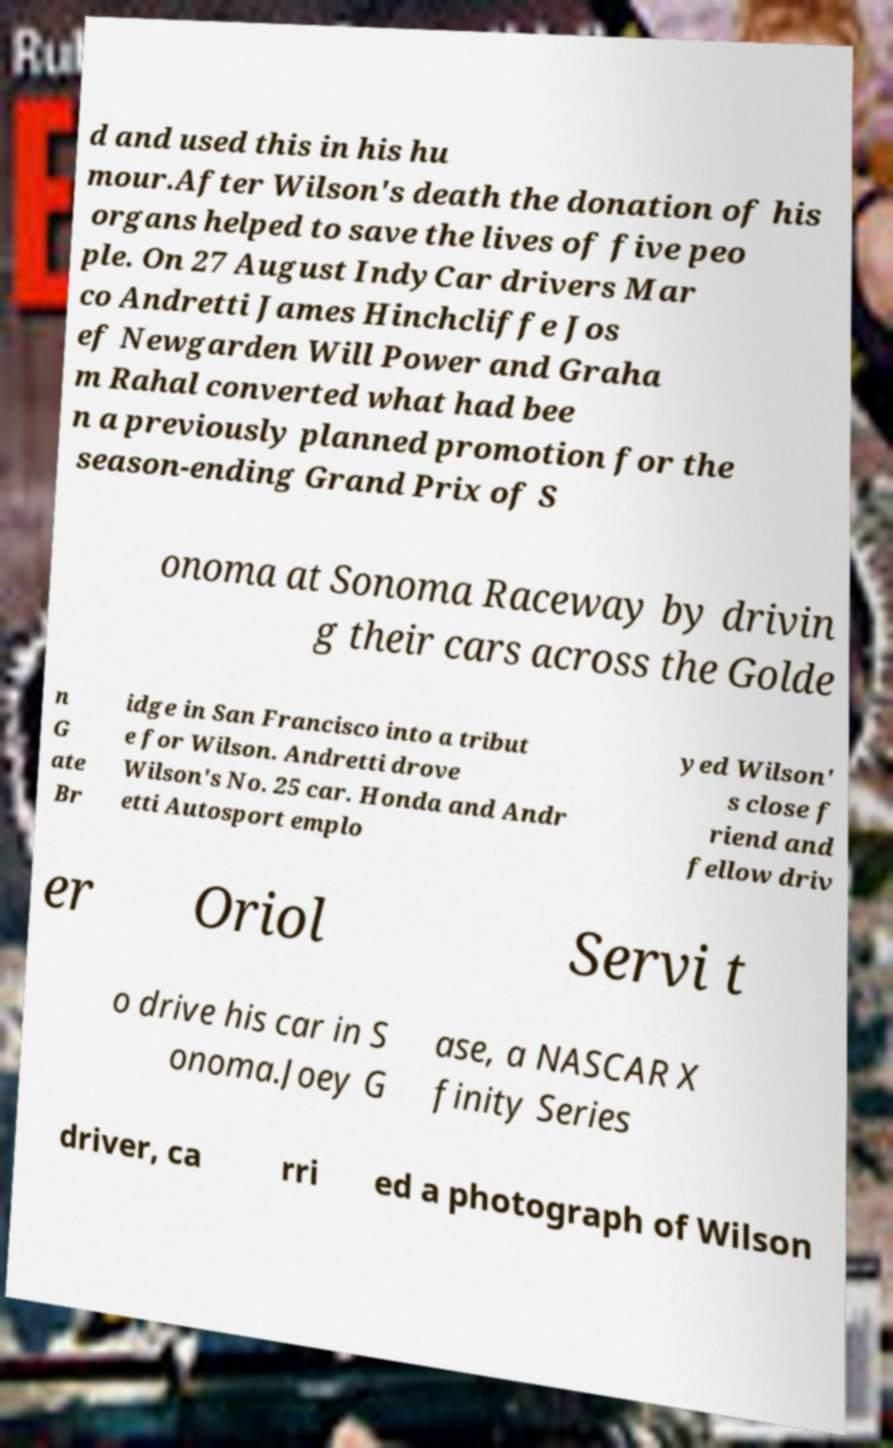What messages or text are displayed in this image? I need them in a readable, typed format. d and used this in his hu mour.After Wilson's death the donation of his organs helped to save the lives of five peo ple. On 27 August IndyCar drivers Mar co Andretti James Hinchcliffe Jos ef Newgarden Will Power and Graha m Rahal converted what had bee n a previously planned promotion for the season-ending Grand Prix of S onoma at Sonoma Raceway by drivin g their cars across the Golde n G ate Br idge in San Francisco into a tribut e for Wilson. Andretti drove Wilson's No. 25 car. Honda and Andr etti Autosport emplo yed Wilson' s close f riend and fellow driv er Oriol Servi t o drive his car in S onoma.Joey G ase, a NASCAR X finity Series driver, ca rri ed a photograph of Wilson 